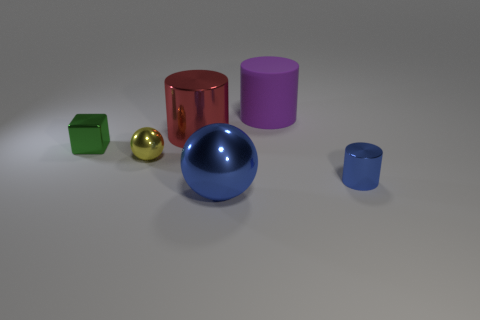Add 4 small metal cubes. How many objects exist? 10 Subtract all cubes. How many objects are left? 5 Add 4 tiny metallic things. How many tiny metallic things exist? 7 Subtract 1 red cylinders. How many objects are left? 5 Subtract all metal balls. Subtract all rubber objects. How many objects are left? 3 Add 4 yellow metal spheres. How many yellow metal spheres are left? 5 